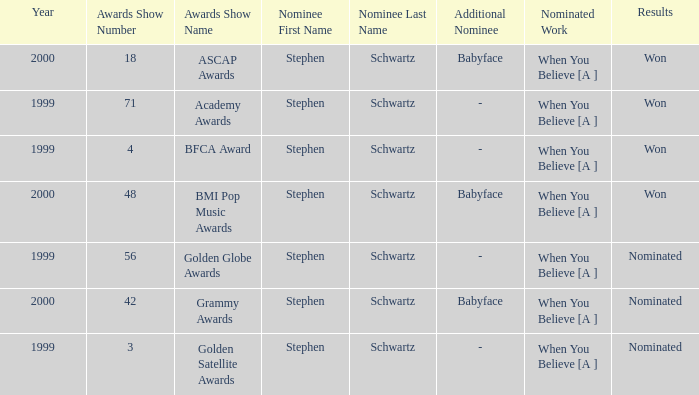What was the outcome in the year 2000? Won, Won, Nominated. I'm looking to parse the entire table for insights. Could you assist me with that? {'header': ['Year', 'Awards Show Number', 'Awards Show Name', 'Nominee First Name', 'Nominee Last Name', 'Additional Nominee', 'Nominated Work', 'Results'], 'rows': [['2000', '18', 'ASCAP Awards', 'Stephen', 'Schwartz', 'Babyface', 'When You Believe [A ]', 'Won'], ['1999', '71', 'Academy Awards', 'Stephen', 'Schwartz', '-', 'When You Believe [A ]', 'Won'], ['1999', '4', 'BFCA Award', 'Stephen', 'Schwartz', '-', 'When You Believe [A ]', 'Won'], ['2000', '48', 'BMI Pop Music Awards', 'Stephen', 'Schwartz', 'Babyface', 'When You Believe [A ]', 'Won'], ['1999', '56', 'Golden Globe Awards', 'Stephen', 'Schwartz', '-', 'When You Believe [A ]', 'Nominated'], ['2000', '42', 'Grammy Awards', 'Stephen', 'Schwartz', 'Babyface', 'When You Believe [A ]', 'Nominated'], ['1999', '3', 'Golden Satellite Awards', 'Stephen', 'Schwartz', '-', 'When You Believe [A ]', 'Nominated']]} 